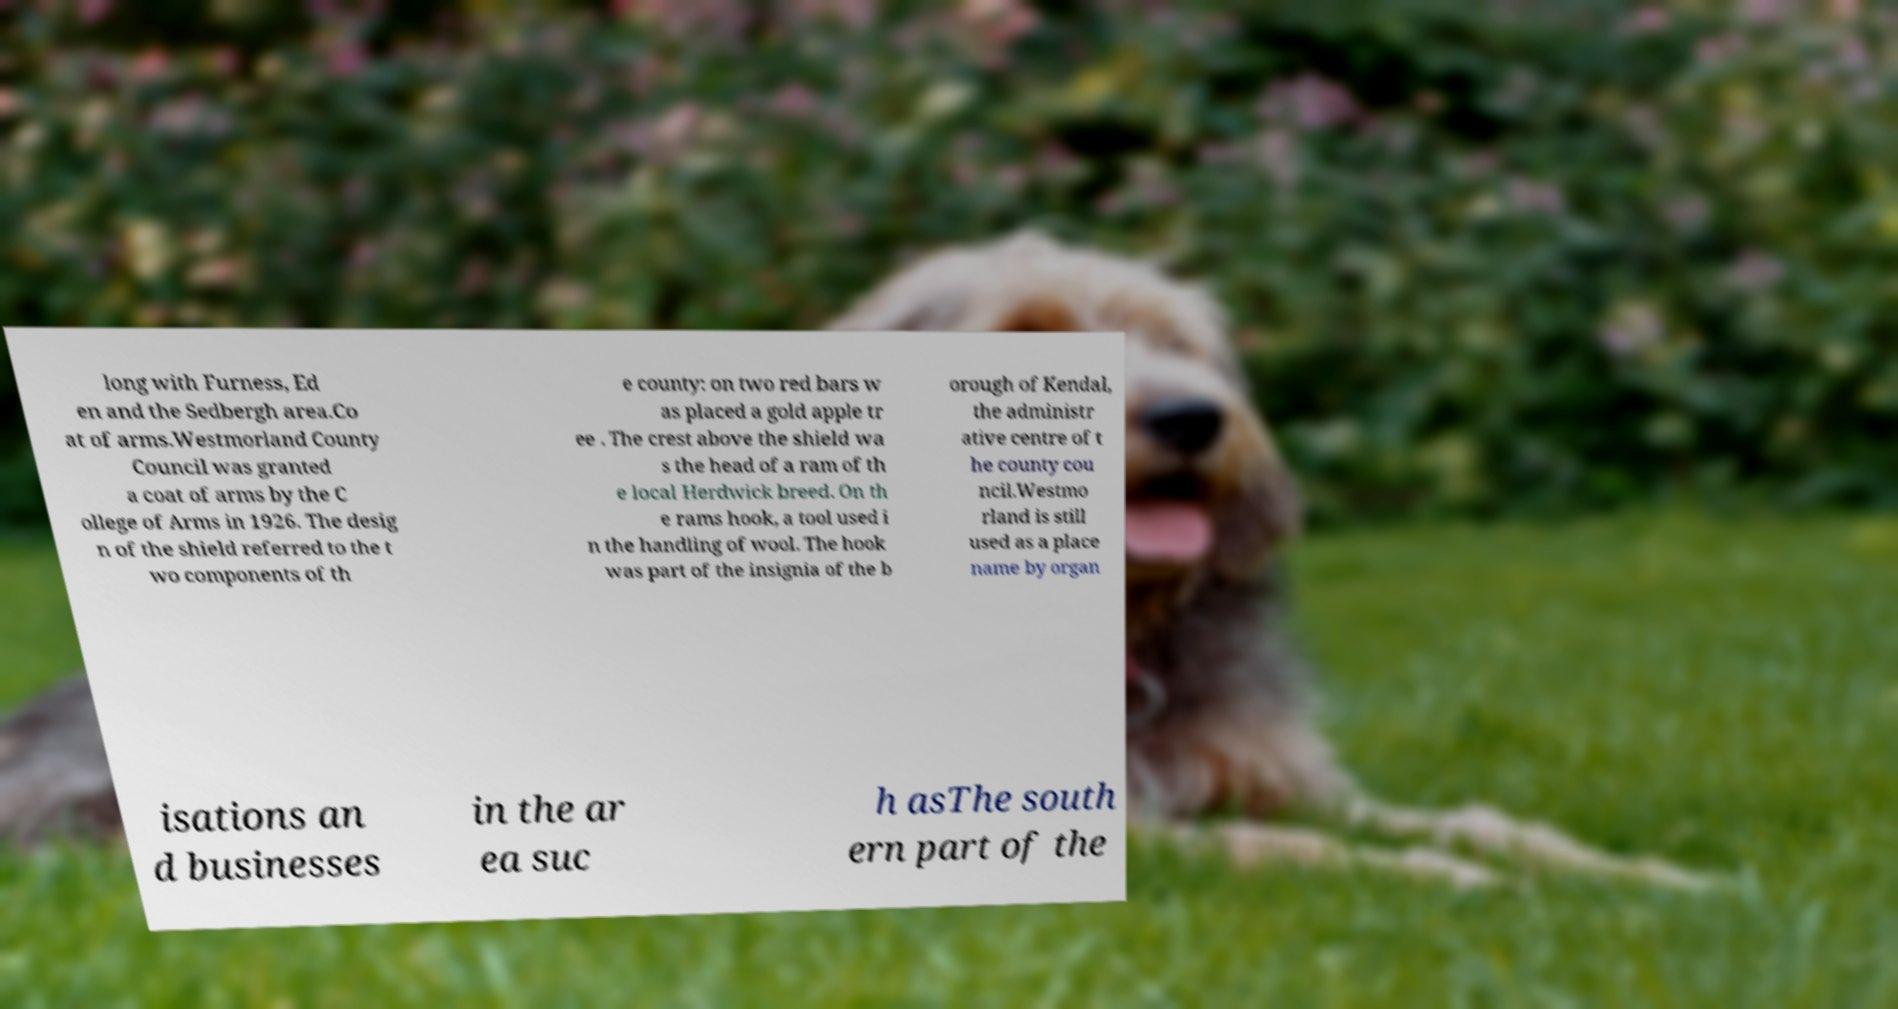Please identify and transcribe the text found in this image. long with Furness, Ed en and the Sedbergh area.Co at of arms.Westmorland County Council was granted a coat of arms by the C ollege of Arms in 1926. The desig n of the shield referred to the t wo components of th e county: on two red bars w as placed a gold apple tr ee . The crest above the shield wa s the head of a ram of th e local Herdwick breed. On th e rams hook, a tool used i n the handling of wool. The hook was part of the insignia of the b orough of Kendal, the administr ative centre of t he county cou ncil.Westmo rland is still used as a place name by organ isations an d businesses in the ar ea suc h asThe south ern part of the 